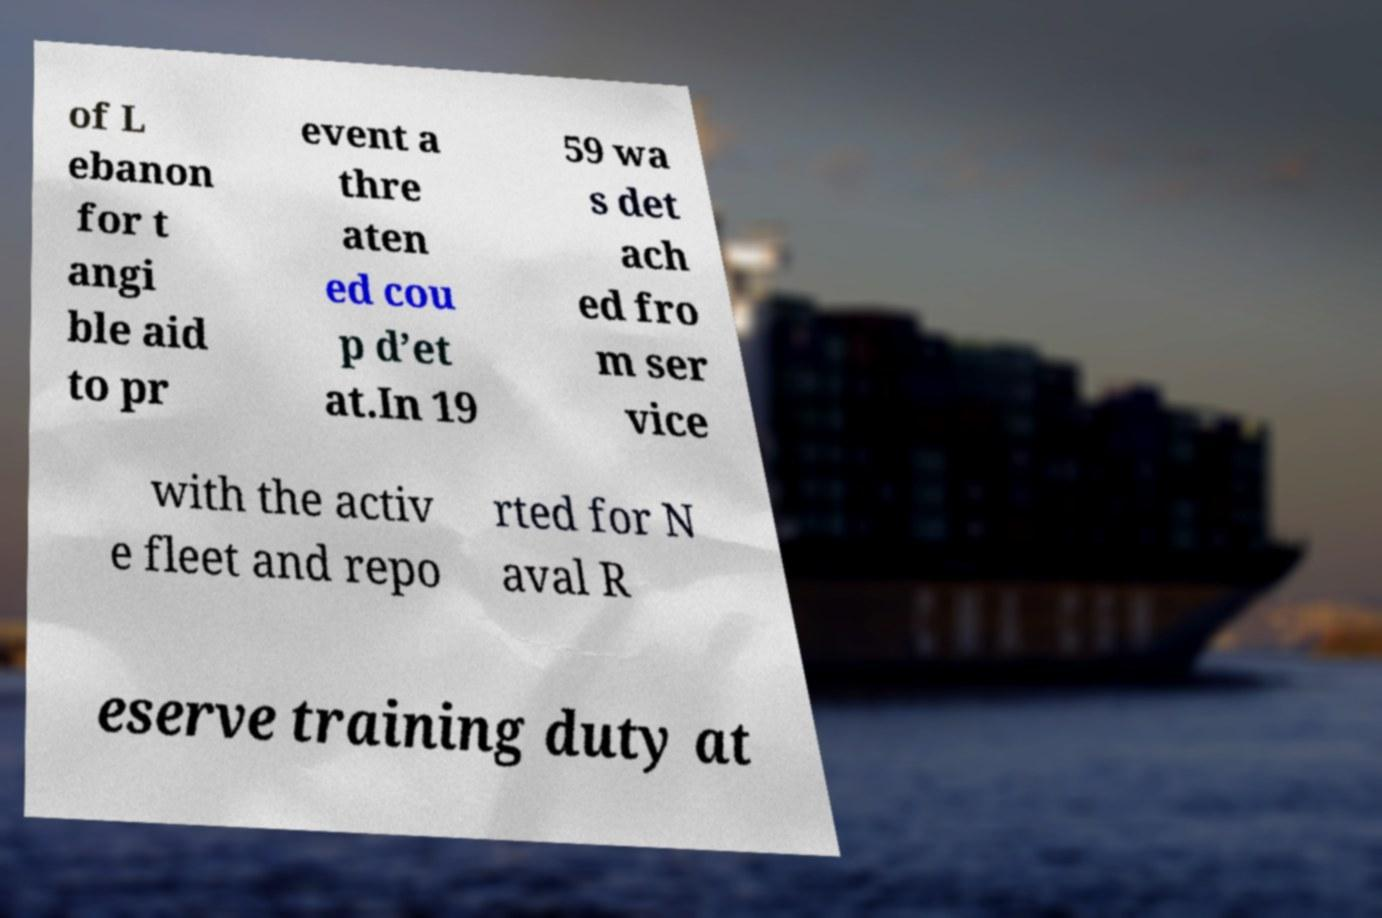What messages or text are displayed in this image? I need them in a readable, typed format. of L ebanon for t angi ble aid to pr event a thre aten ed cou p d’et at.In 19 59 wa s det ach ed fro m ser vice with the activ e fleet and repo rted for N aval R eserve training duty at 